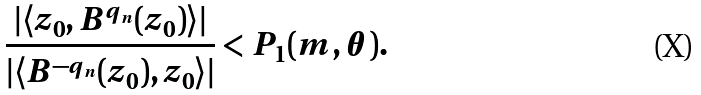<formula> <loc_0><loc_0><loc_500><loc_500>\frac { | \langle z _ { 0 } , { B } ^ { q _ { n } } ( z _ { 0 } ) \rangle | } { | \langle { B } ^ { - q _ { n } } ( z _ { 0 } ) , z _ { 0 } \rangle | } < P _ { 1 } ( m , \theta ) .</formula> 